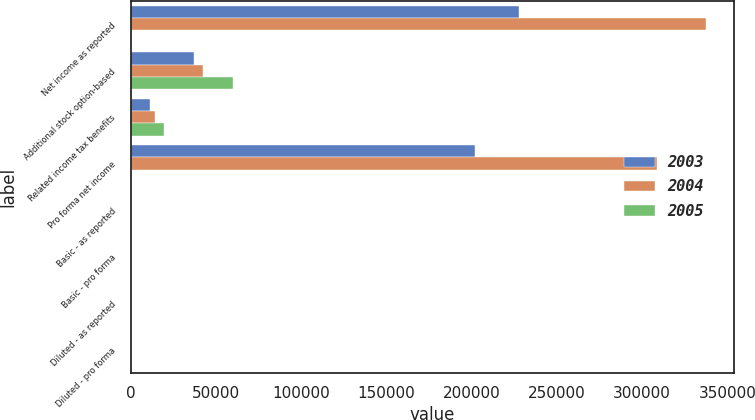Convert chart. <chart><loc_0><loc_0><loc_500><loc_500><stacked_bar_chart><ecel><fcel>Net income as reported<fcel>Additional stock option-based<fcel>Related income tax benefits<fcel>Pro forma net income<fcel>Basic - as reported<fcel>Basic - pro forma<fcel>Diluted - as reported<fcel>Diluted - pro forma<nl><fcel>2003<fcel>227487<fcel>37028<fcel>11248<fcel>201707<fcel>1.84<fcel>1.63<fcel>1.77<fcel>1.59<nl><fcel>2004<fcel>337260<fcel>42631<fcel>14167<fcel>308796<fcel>2.65<fcel>2.42<fcel>2.51<fcel>2.31<nl><fcel>2005<fcel>3.23<fcel>59829<fcel>19566<fcel>3.23<fcel>3.31<fcel>3<fcel>3.15<fcel>2.85<nl></chart> 